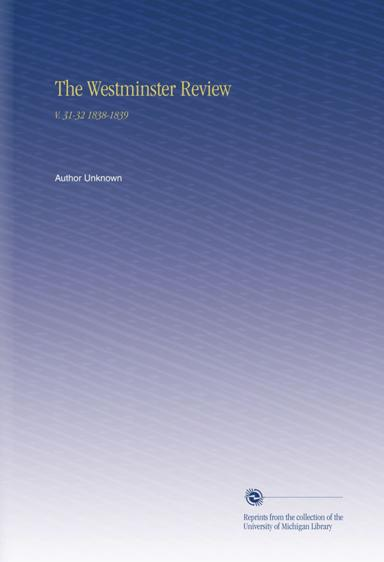What is the topic of the text mentioned in the image? The image features a cover of a book titled 'The Westminster Review V.31-32 1838-1839,' indicating its content revolves around various articles or discussions published in the Westminster Review during the years 1838 and 1839. This historical publication often included writings on politics, philosophy, science, and arts, reflecting intellectual and scholarly debates of the period. 